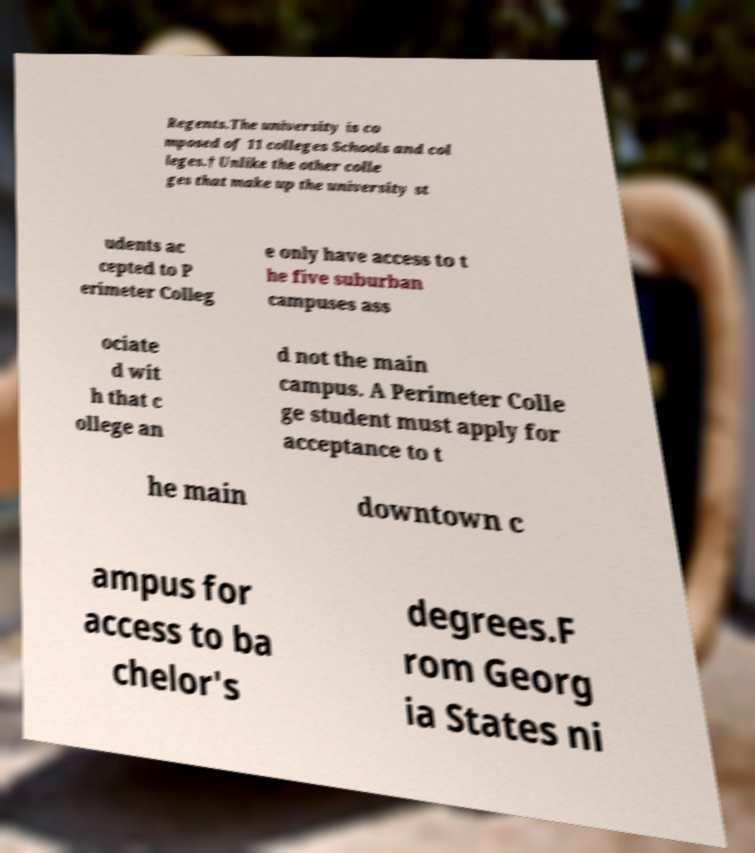I need the written content from this picture converted into text. Can you do that? Regents.The university is co mposed of 11 colleges Schools and col leges.† Unlike the other colle ges that make up the university st udents ac cepted to P erimeter Colleg e only have access to t he five suburban campuses ass ociate d wit h that c ollege an d not the main campus. A Perimeter Colle ge student must apply for acceptance to t he main downtown c ampus for access to ba chelor's degrees.F rom Georg ia States ni 